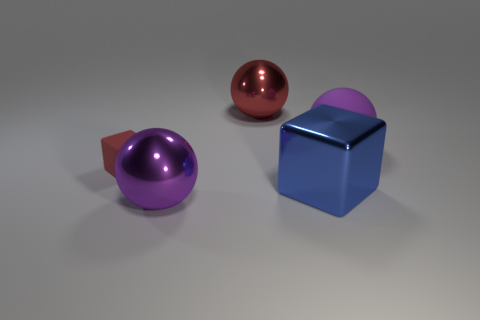Are the big purple object right of the blue shiny thing and the tiny object made of the same material?
Provide a succinct answer. Yes. Is the big blue shiny thing the same shape as the red rubber object?
Make the answer very short. Yes. What number of objects are spheres that are behind the small thing or cubes?
Offer a very short reply. 4. The purple ball that is made of the same material as the small red thing is what size?
Your answer should be compact. Large. How many big cubes have the same color as the small object?
Provide a short and direct response. 0. What number of large objects are red rubber things or cylinders?
Ensure brevity in your answer.  0. Is there another object that has the same material as the tiny thing?
Offer a very short reply. Yes. There is a big purple object that is behind the red rubber block; what material is it?
Your response must be concise. Rubber. Is the color of the thing that is right of the large blue shiny cube the same as the big object that is in front of the big blue cube?
Provide a short and direct response. Yes. There is a shiny cube that is the same size as the purple metallic sphere; what color is it?
Your answer should be compact. Blue. 